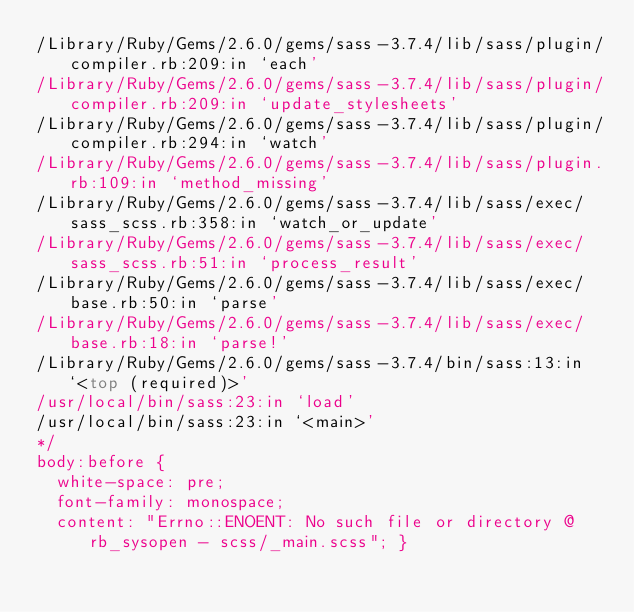<code> <loc_0><loc_0><loc_500><loc_500><_CSS_>/Library/Ruby/Gems/2.6.0/gems/sass-3.7.4/lib/sass/plugin/compiler.rb:209:in `each'
/Library/Ruby/Gems/2.6.0/gems/sass-3.7.4/lib/sass/plugin/compiler.rb:209:in `update_stylesheets'
/Library/Ruby/Gems/2.6.0/gems/sass-3.7.4/lib/sass/plugin/compiler.rb:294:in `watch'
/Library/Ruby/Gems/2.6.0/gems/sass-3.7.4/lib/sass/plugin.rb:109:in `method_missing'
/Library/Ruby/Gems/2.6.0/gems/sass-3.7.4/lib/sass/exec/sass_scss.rb:358:in `watch_or_update'
/Library/Ruby/Gems/2.6.0/gems/sass-3.7.4/lib/sass/exec/sass_scss.rb:51:in `process_result'
/Library/Ruby/Gems/2.6.0/gems/sass-3.7.4/lib/sass/exec/base.rb:50:in `parse'
/Library/Ruby/Gems/2.6.0/gems/sass-3.7.4/lib/sass/exec/base.rb:18:in `parse!'
/Library/Ruby/Gems/2.6.0/gems/sass-3.7.4/bin/sass:13:in `<top (required)>'
/usr/local/bin/sass:23:in `load'
/usr/local/bin/sass:23:in `<main>'
*/
body:before {
  white-space: pre;
  font-family: monospace;
  content: "Errno::ENOENT: No such file or directory @ rb_sysopen - scss/_main.scss"; }
</code> 